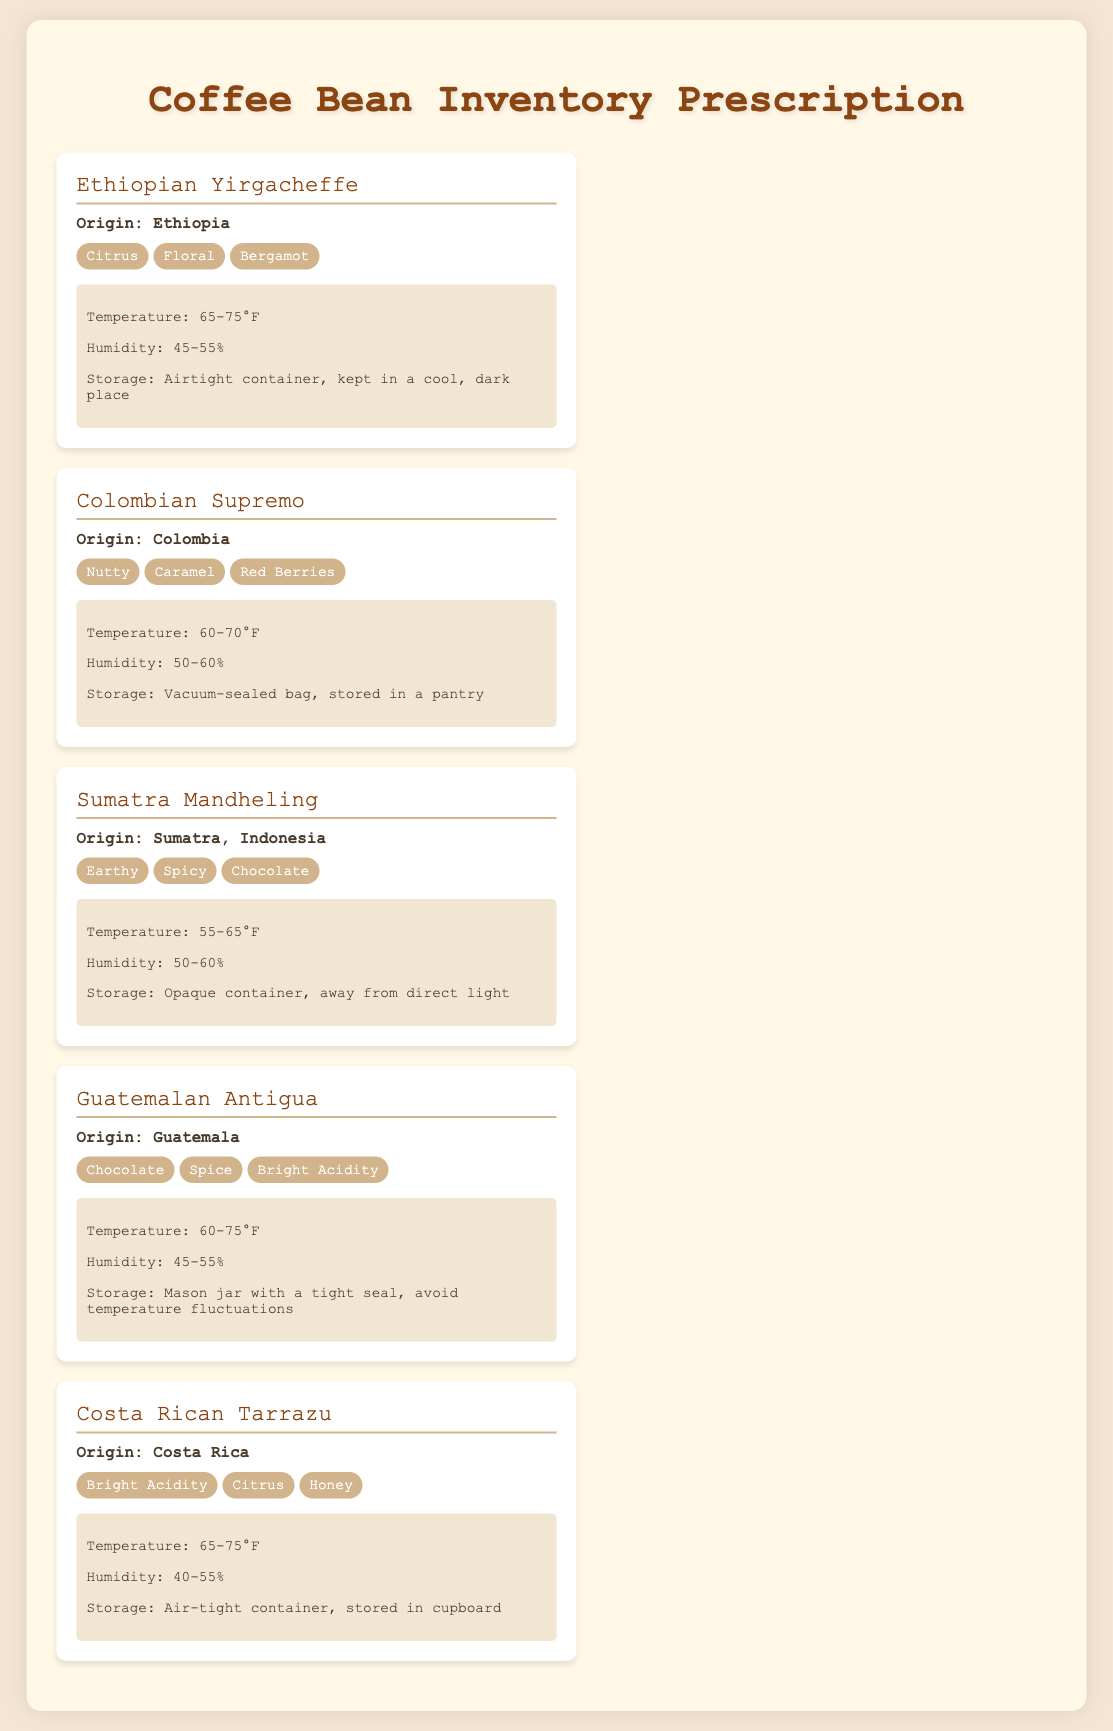What is the origin of Ethiopian Yirgacheffe? The origin of Ethiopian Yirgacheffe is explicitly stated in the document.
Answer: Ethiopia What flavor profile is associated with Colombian Supremo? The document lists specific flavor tags for Colombian Supremo under its flavor profiles.
Answer: Nutty, Caramel, Red Berries What is the storage temperature range for Sumatra Mandheling? The document provides the storage details, including temperature range for all beans.
Answer: 55-65°F Which bean has a storage recommendation of an opaque container? The document clearly mentions the recommended storage conditions for each bean.
Answer: Sumatra Mandheling How many flavor tags are listed for Guatemalan Antigua? The document specifies the flavor profiles for each coffee and counts are easily visible.
Answer: 3 What humidity level is recommended for Costa Rican Tarrazu? The document lists the recommended humidity for each coffee bean under storage details.
Answer: 40-55% What flavor profile is unique to Ethiopian Yirgacheffe compared to the other beans? The document allows for comparison of unique flavors based on listed flavor tags per bean.
Answer: Floral Which coffee bean is suggested to be kept in a vacuum-sealed bag? The storage details indicate specific recommendations for each coffee bean.
Answer: Colombian Supremo 